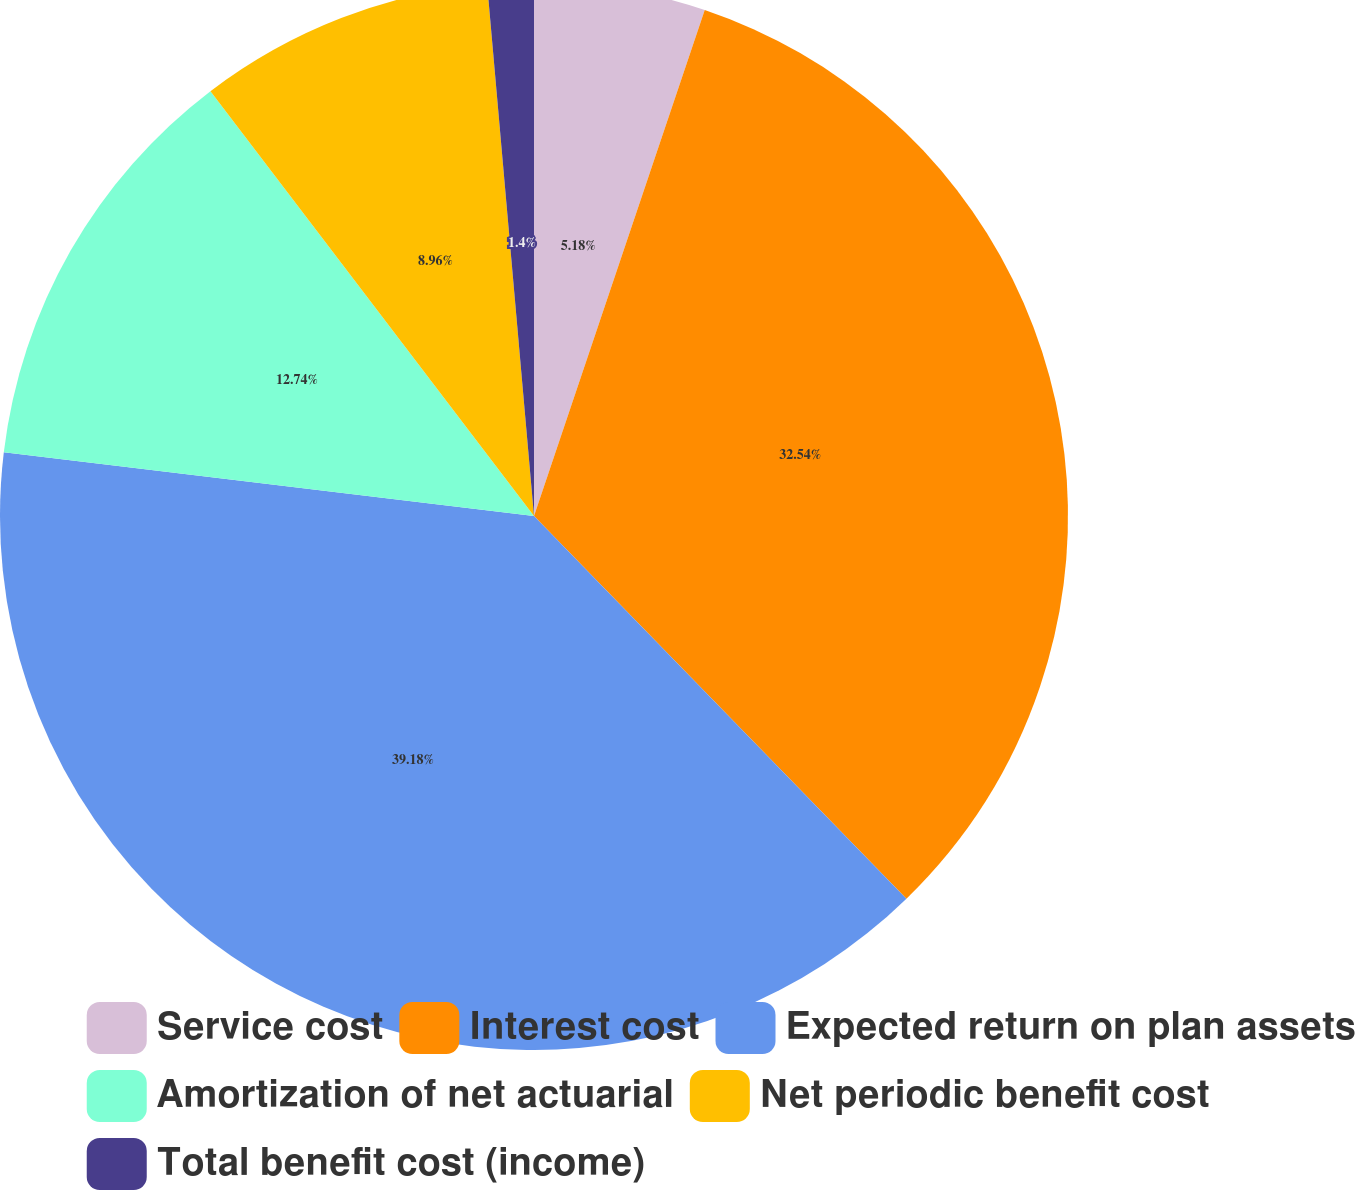Convert chart. <chart><loc_0><loc_0><loc_500><loc_500><pie_chart><fcel>Service cost<fcel>Interest cost<fcel>Expected return on plan assets<fcel>Amortization of net actuarial<fcel>Net periodic benefit cost<fcel>Total benefit cost (income)<nl><fcel>5.18%<fcel>32.54%<fcel>39.19%<fcel>12.74%<fcel>8.96%<fcel>1.4%<nl></chart> 